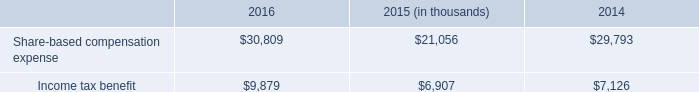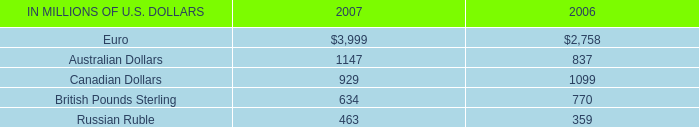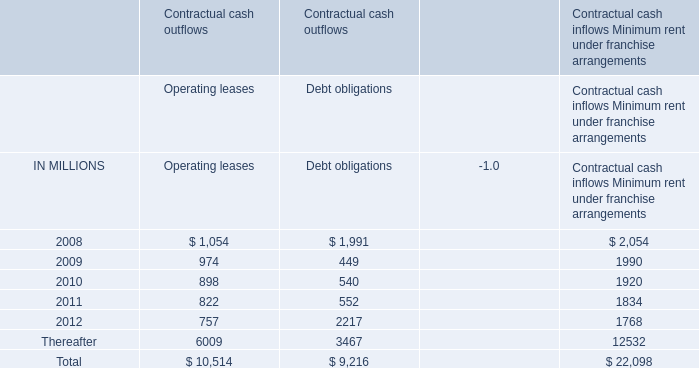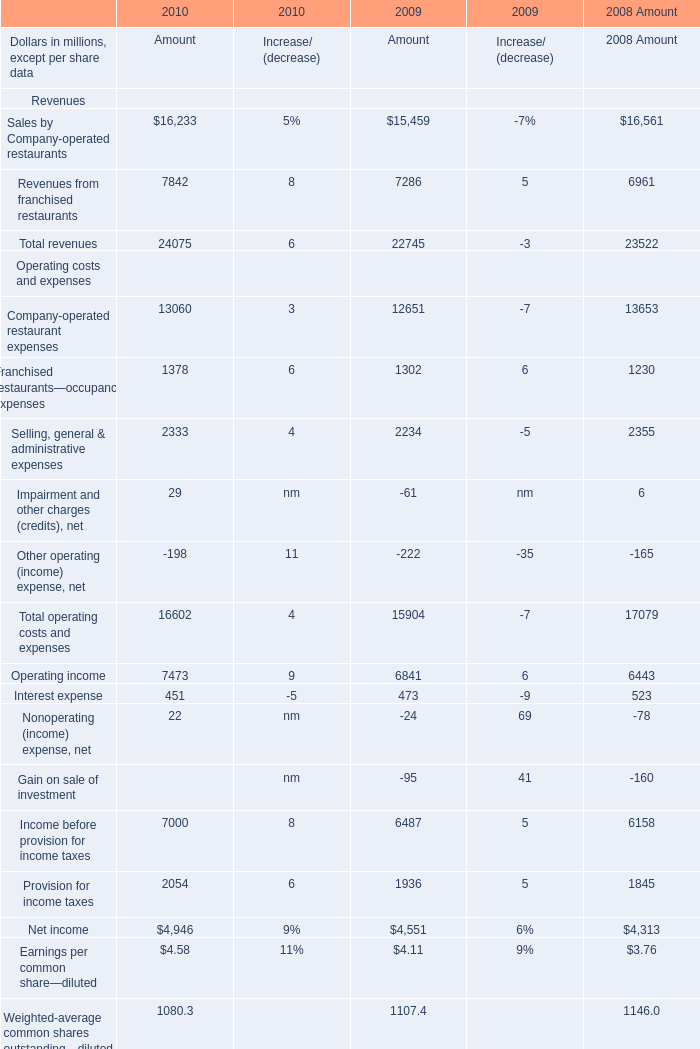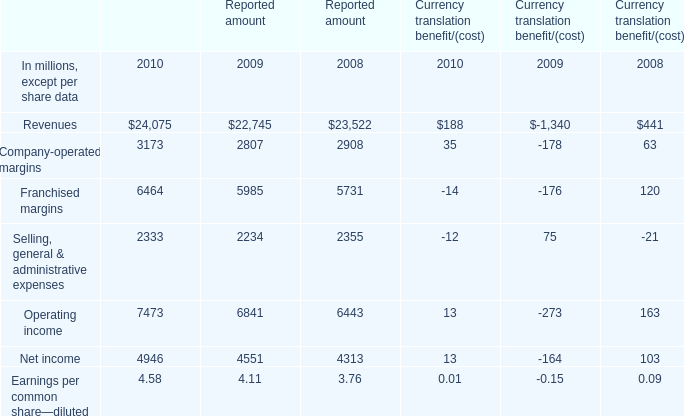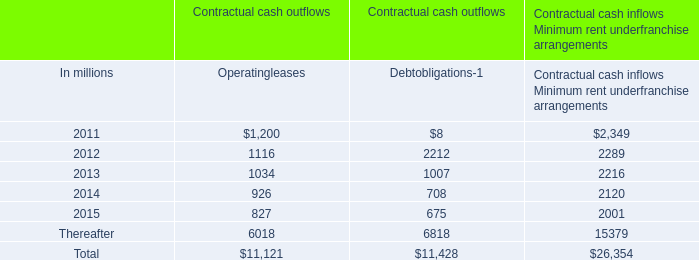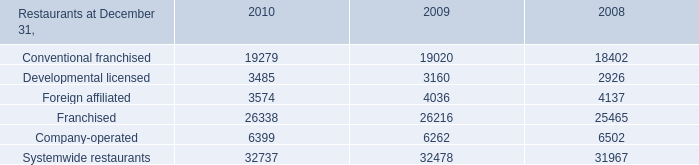What is the growing rate of Operating income for Amout in the years with the least Interest expense for Amount? 
Computations: ((7473 - 6841) / 6841)
Answer: 0.09238. 